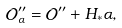Convert formula to latex. <formula><loc_0><loc_0><loc_500><loc_500>\mathcal { O } ^ { \prime \prime } _ { \alpha } = \mathcal { O } ^ { \prime \prime } + H _ { \ast } \alpha ,</formula> 